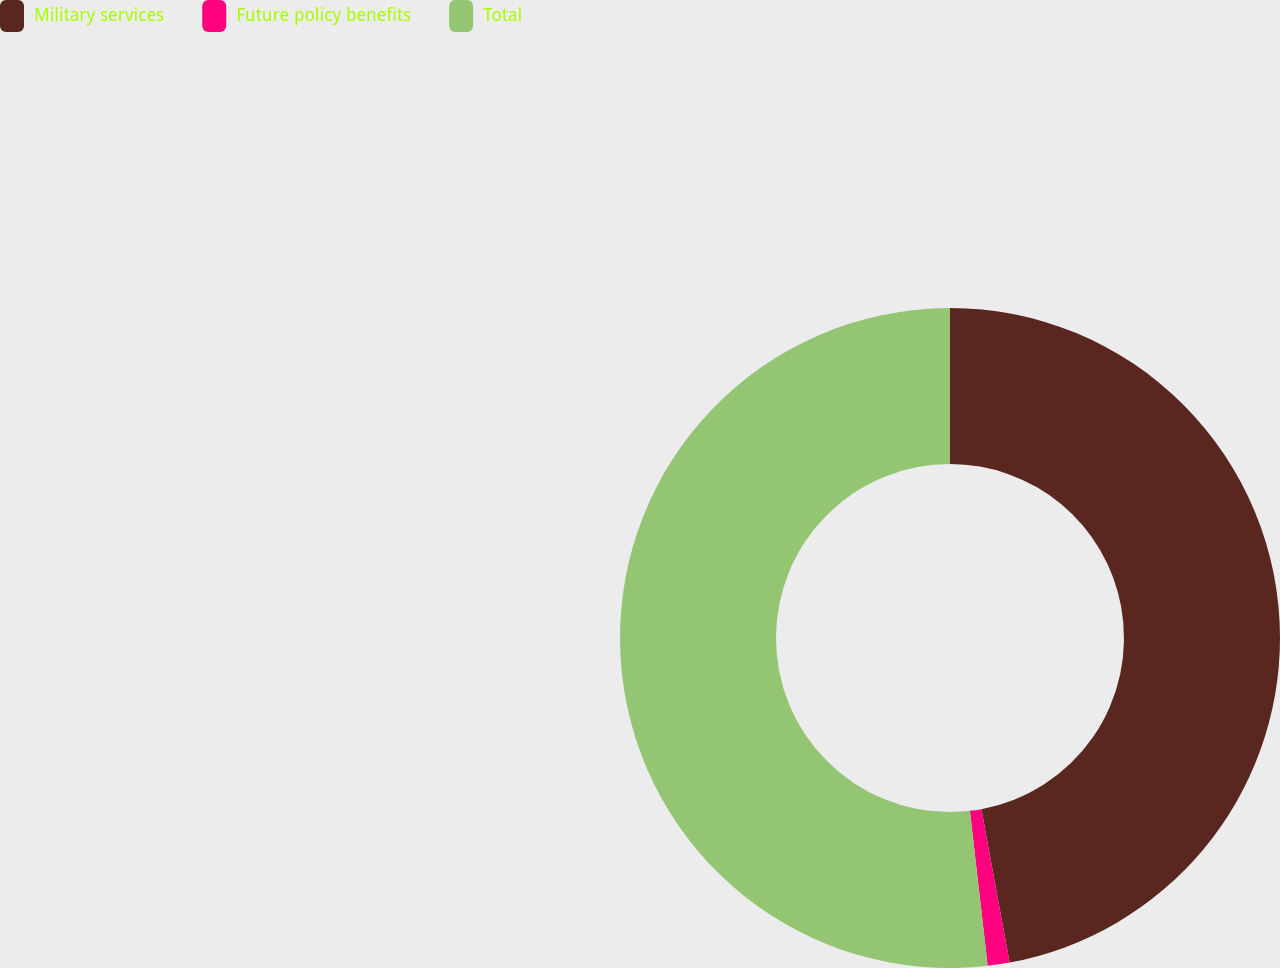Convert chart to OTSL. <chart><loc_0><loc_0><loc_500><loc_500><pie_chart><fcel>Military services<fcel>Future policy benefits<fcel>Total<nl><fcel>47.11%<fcel>1.07%<fcel>51.82%<nl></chart> 